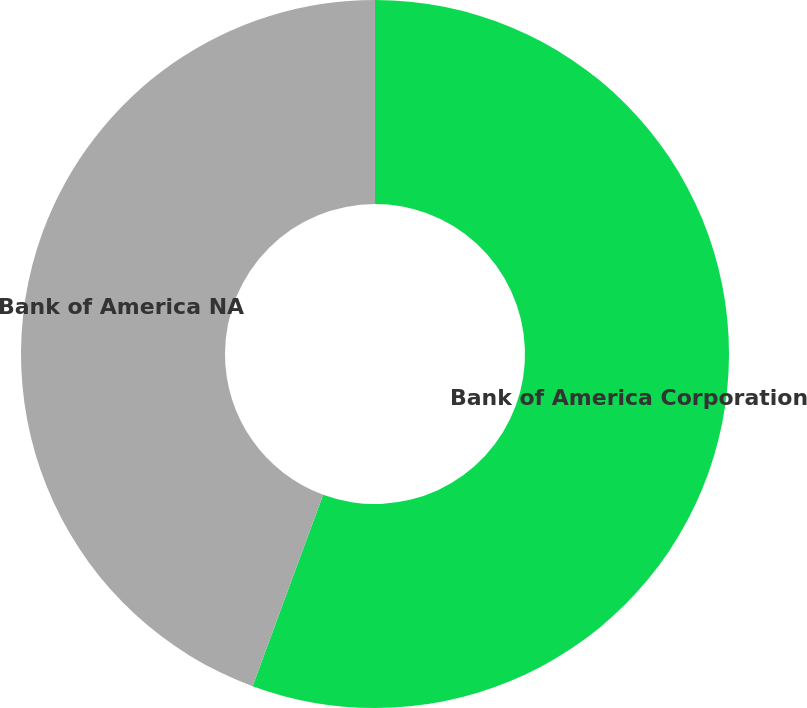<chart> <loc_0><loc_0><loc_500><loc_500><pie_chart><fcel>Bank of America Corporation<fcel>Bank of America NA<nl><fcel>55.62%<fcel>44.38%<nl></chart> 